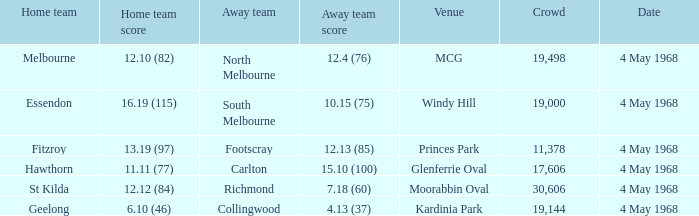How big was the crowd of the team that scored 4.13 (37)? 19144.0. 